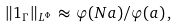Convert formula to latex. <formula><loc_0><loc_0><loc_500><loc_500>\| 1 _ { \Gamma } \| _ { L ^ { \Phi } } \, \approx \, { \varphi ( N a ) } / { \varphi ( a ) } \, ,</formula> 